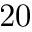Convert formula to latex. <formula><loc_0><loc_0><loc_500><loc_500>2 0</formula> 